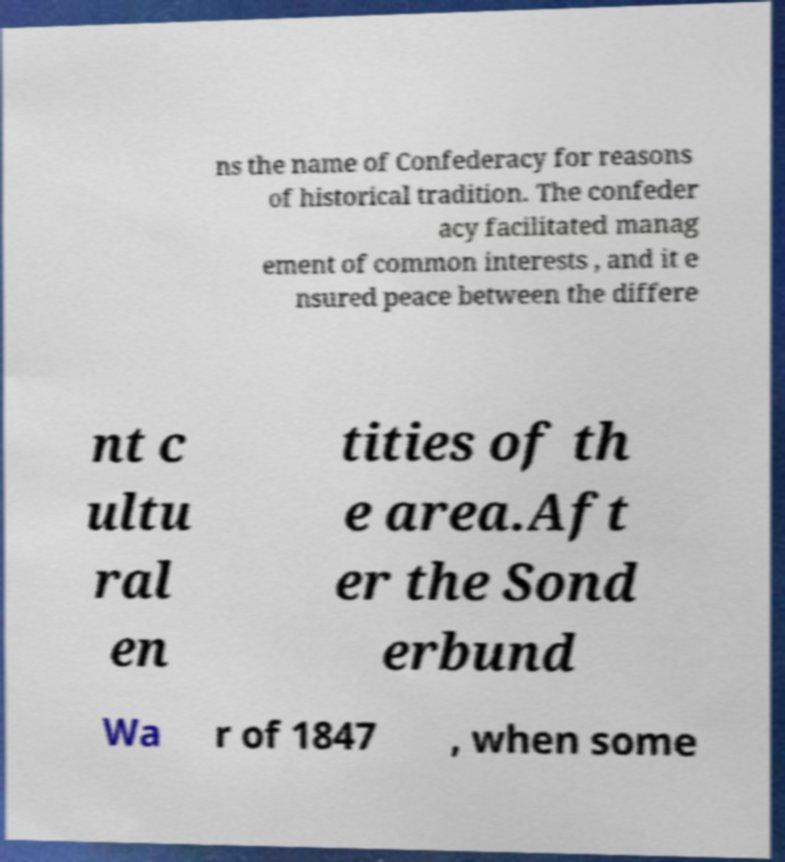Please identify and transcribe the text found in this image. ns the name of Confederacy for reasons of historical tradition. The confeder acy facilitated manag ement of common interests , and it e nsured peace between the differe nt c ultu ral en tities of th e area.Aft er the Sond erbund Wa r of 1847 , when some 